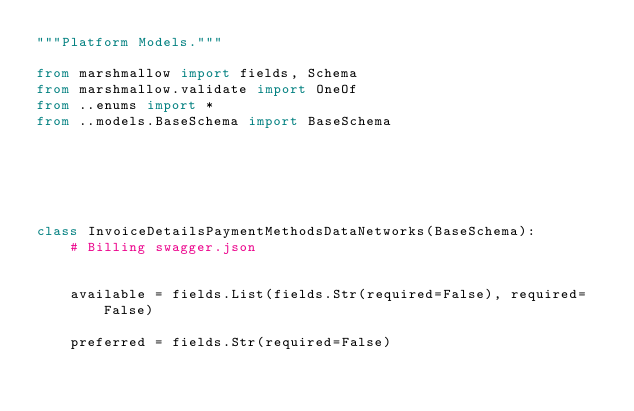<code> <loc_0><loc_0><loc_500><loc_500><_Python_>"""Platform Models."""

from marshmallow import fields, Schema
from marshmallow.validate import OneOf
from ..enums import *
from ..models.BaseSchema import BaseSchema






class InvoiceDetailsPaymentMethodsDataNetworks(BaseSchema):
    # Billing swagger.json

    
    available = fields.List(fields.Str(required=False), required=False)
    
    preferred = fields.Str(required=False)
    

</code> 